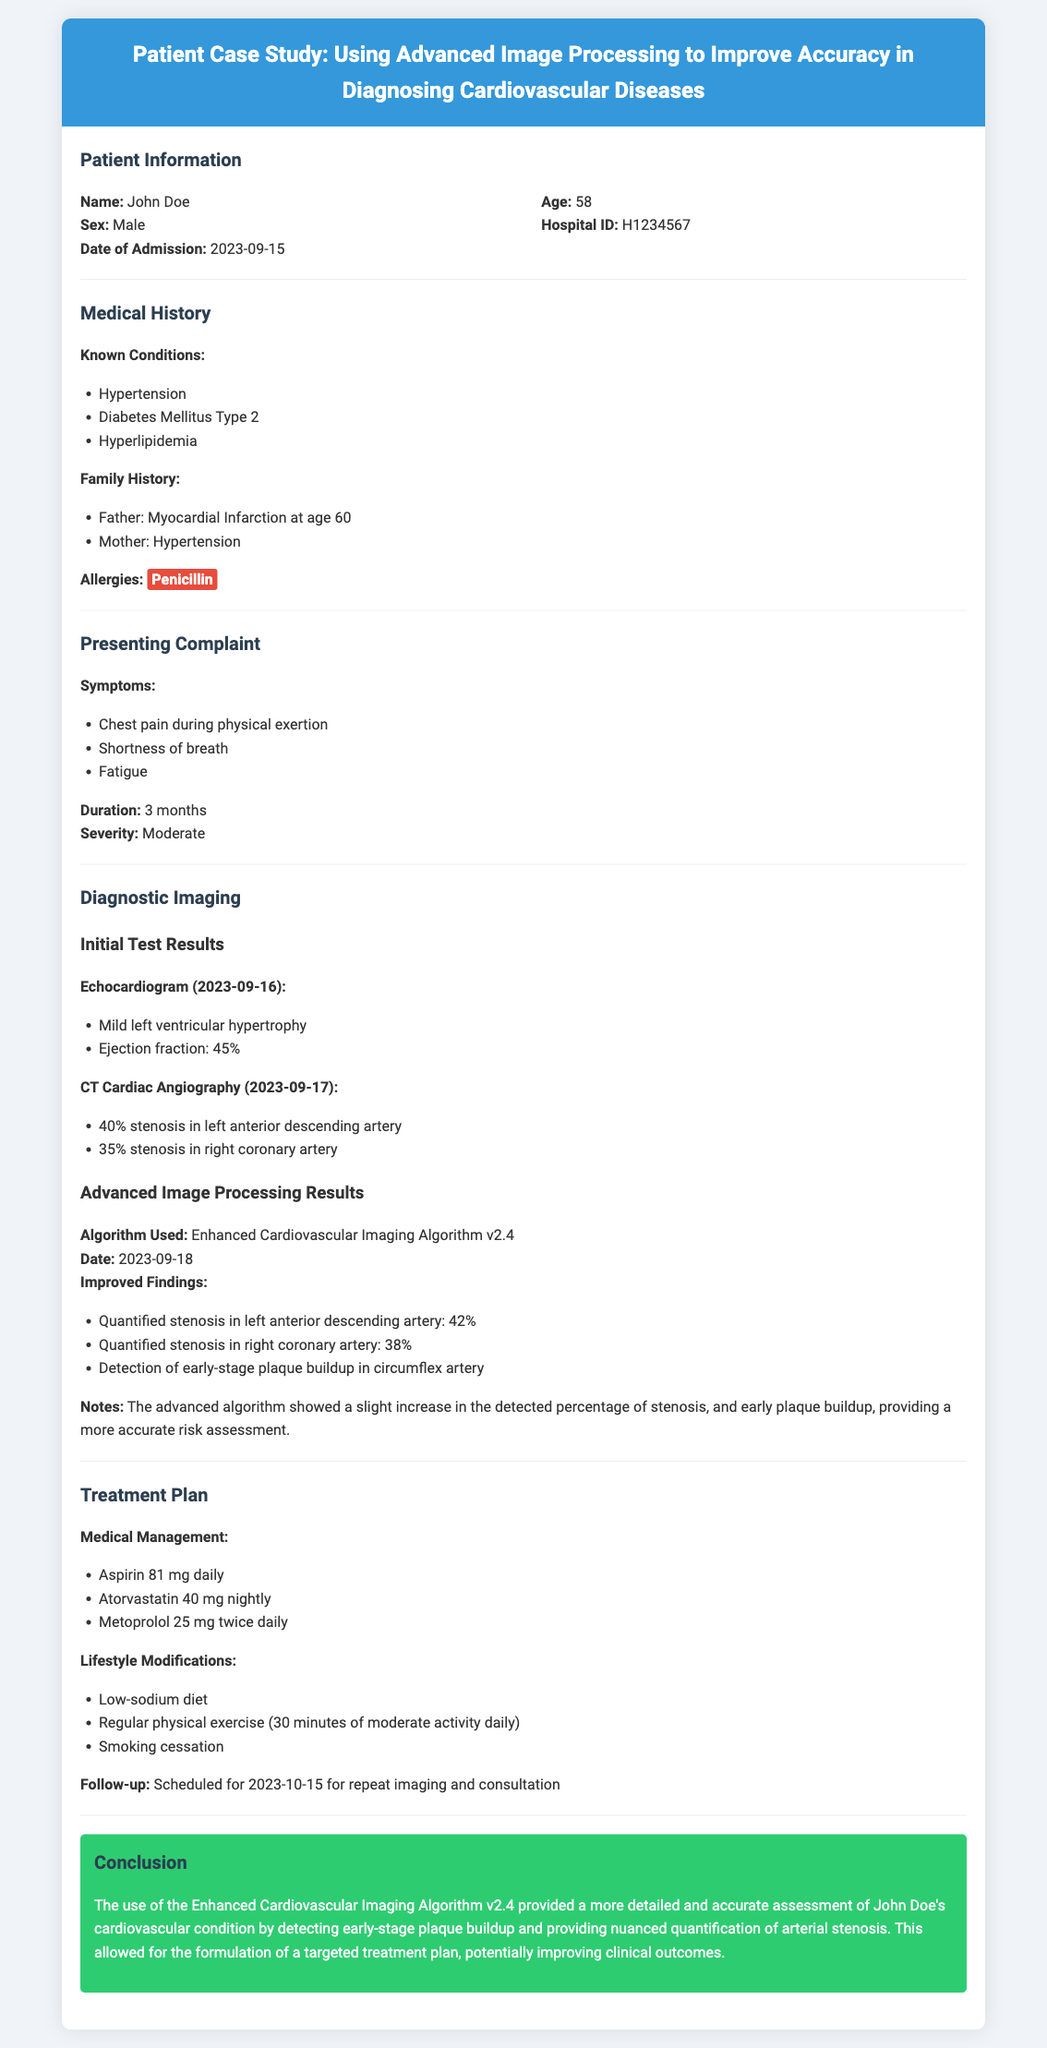What is the patient's name? The patient's name is stated clearly at the beginning of the document under Patient Information.
Answer: John Doe What is the patient's age? The age of the patient is provided in the Patient Information section.
Answer: 58 What is the date of admission? The date of admission is listed in the Patient Information section.
Answer: 2023-09-15 What medical condition is the patient allergic to? The patient's allergies are mentioned in the Medical History section.
Answer: Penicillin What was the ejection fraction observed in the echocardiogram? The ejection fraction is reported in the Initial Test Results of the Diagnostic Imaging section.
Answer: 45% What algorithm was used for advanced image processing? The algorithm used is specified in the Advanced Image Processing Results section.
Answer: Enhanced Cardiovascular Imaging Algorithm v2.4 What stenosis percentage was quantified in the right coronary artery? The quantified stenosis percentage is detailed in the Advanced Image Processing Results section.
Answer: 38% What follow-up date is scheduled for the patient? The follow-up date is indicated in the Treatment Plan section.
Answer: 2023-10-15 What lifestyle modification includes regular exercise? The lifestyle modifications listed under Treatment Plan mention this clearly.
Answer: Regular physical exercise (30 minutes of moderate activity daily) 